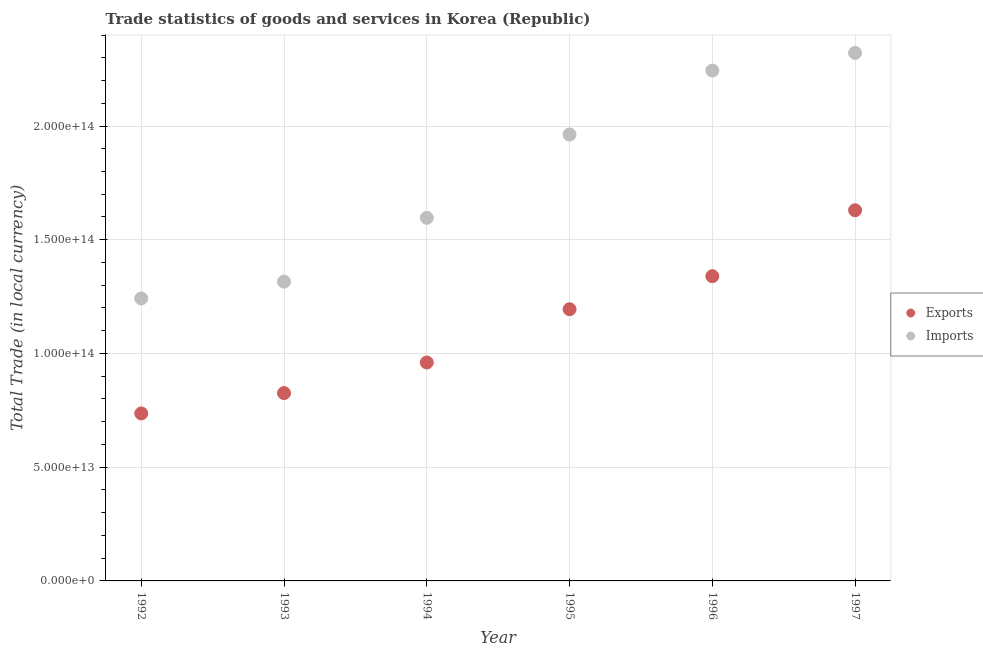What is the export of goods and services in 1995?
Ensure brevity in your answer.  1.19e+14. Across all years, what is the maximum imports of goods and services?
Your answer should be very brief. 2.32e+14. Across all years, what is the minimum export of goods and services?
Ensure brevity in your answer.  7.36e+13. What is the total imports of goods and services in the graph?
Offer a terse response. 1.07e+15. What is the difference between the imports of goods and services in 1995 and that in 1996?
Offer a very short reply. -2.81e+13. What is the difference between the imports of goods and services in 1996 and the export of goods and services in 1992?
Make the answer very short. 1.51e+14. What is the average imports of goods and services per year?
Provide a short and direct response. 1.78e+14. In the year 1995, what is the difference between the export of goods and services and imports of goods and services?
Make the answer very short. -7.68e+13. In how many years, is the export of goods and services greater than 130000000000000 LCU?
Provide a short and direct response. 2. What is the ratio of the imports of goods and services in 1993 to that in 1996?
Ensure brevity in your answer.  0.59. Is the difference between the export of goods and services in 1992 and 1997 greater than the difference between the imports of goods and services in 1992 and 1997?
Give a very brief answer. Yes. What is the difference between the highest and the second highest export of goods and services?
Offer a terse response. 2.90e+13. What is the difference between the highest and the lowest export of goods and services?
Provide a succinct answer. 8.93e+13. In how many years, is the export of goods and services greater than the average export of goods and services taken over all years?
Your answer should be very brief. 3. Is the sum of the imports of goods and services in 1994 and 1995 greater than the maximum export of goods and services across all years?
Your answer should be very brief. Yes. Does the imports of goods and services monotonically increase over the years?
Give a very brief answer. Yes. Is the export of goods and services strictly greater than the imports of goods and services over the years?
Give a very brief answer. No. Is the export of goods and services strictly less than the imports of goods and services over the years?
Ensure brevity in your answer.  Yes. What is the difference between two consecutive major ticks on the Y-axis?
Give a very brief answer. 5.00e+13. Are the values on the major ticks of Y-axis written in scientific E-notation?
Make the answer very short. Yes. How many legend labels are there?
Keep it short and to the point. 2. How are the legend labels stacked?
Give a very brief answer. Vertical. What is the title of the graph?
Your answer should be compact. Trade statistics of goods and services in Korea (Republic). Does "Commercial service imports" appear as one of the legend labels in the graph?
Keep it short and to the point. No. What is the label or title of the Y-axis?
Offer a terse response. Total Trade (in local currency). What is the Total Trade (in local currency) in Exports in 1992?
Provide a short and direct response. 7.36e+13. What is the Total Trade (in local currency) in Imports in 1992?
Your answer should be very brief. 1.24e+14. What is the Total Trade (in local currency) in Exports in 1993?
Your response must be concise. 8.26e+13. What is the Total Trade (in local currency) in Imports in 1993?
Ensure brevity in your answer.  1.32e+14. What is the Total Trade (in local currency) in Exports in 1994?
Offer a very short reply. 9.60e+13. What is the Total Trade (in local currency) in Imports in 1994?
Offer a very short reply. 1.60e+14. What is the Total Trade (in local currency) of Exports in 1995?
Offer a very short reply. 1.19e+14. What is the Total Trade (in local currency) of Imports in 1995?
Keep it short and to the point. 1.96e+14. What is the Total Trade (in local currency) of Exports in 1996?
Provide a short and direct response. 1.34e+14. What is the Total Trade (in local currency) of Imports in 1996?
Offer a very short reply. 2.24e+14. What is the Total Trade (in local currency) in Exports in 1997?
Make the answer very short. 1.63e+14. What is the Total Trade (in local currency) in Imports in 1997?
Provide a succinct answer. 2.32e+14. Across all years, what is the maximum Total Trade (in local currency) in Exports?
Make the answer very short. 1.63e+14. Across all years, what is the maximum Total Trade (in local currency) of Imports?
Provide a succinct answer. 2.32e+14. Across all years, what is the minimum Total Trade (in local currency) of Exports?
Your answer should be compact. 7.36e+13. Across all years, what is the minimum Total Trade (in local currency) in Imports?
Provide a succinct answer. 1.24e+14. What is the total Total Trade (in local currency) of Exports in the graph?
Ensure brevity in your answer.  6.69e+14. What is the total Total Trade (in local currency) of Imports in the graph?
Provide a succinct answer. 1.07e+15. What is the difference between the Total Trade (in local currency) in Exports in 1992 and that in 1993?
Offer a terse response. -8.95e+12. What is the difference between the Total Trade (in local currency) of Imports in 1992 and that in 1993?
Offer a very short reply. -7.39e+12. What is the difference between the Total Trade (in local currency) of Exports in 1992 and that in 1994?
Keep it short and to the point. -2.24e+13. What is the difference between the Total Trade (in local currency) of Imports in 1992 and that in 1994?
Give a very brief answer. -3.55e+13. What is the difference between the Total Trade (in local currency) of Exports in 1992 and that in 1995?
Your answer should be very brief. -4.58e+13. What is the difference between the Total Trade (in local currency) in Imports in 1992 and that in 1995?
Offer a terse response. -7.21e+13. What is the difference between the Total Trade (in local currency) in Exports in 1992 and that in 1996?
Make the answer very short. -6.03e+13. What is the difference between the Total Trade (in local currency) in Imports in 1992 and that in 1996?
Make the answer very short. -1.00e+14. What is the difference between the Total Trade (in local currency) in Exports in 1992 and that in 1997?
Your answer should be compact. -8.93e+13. What is the difference between the Total Trade (in local currency) of Imports in 1992 and that in 1997?
Your response must be concise. -1.08e+14. What is the difference between the Total Trade (in local currency) of Exports in 1993 and that in 1994?
Your answer should be compact. -1.34e+13. What is the difference between the Total Trade (in local currency) in Imports in 1993 and that in 1994?
Your response must be concise. -2.81e+13. What is the difference between the Total Trade (in local currency) of Exports in 1993 and that in 1995?
Give a very brief answer. -3.69e+13. What is the difference between the Total Trade (in local currency) in Imports in 1993 and that in 1995?
Your answer should be compact. -6.47e+13. What is the difference between the Total Trade (in local currency) of Exports in 1993 and that in 1996?
Your answer should be very brief. -5.14e+13. What is the difference between the Total Trade (in local currency) of Imports in 1993 and that in 1996?
Your answer should be very brief. -9.28e+13. What is the difference between the Total Trade (in local currency) of Exports in 1993 and that in 1997?
Keep it short and to the point. -8.04e+13. What is the difference between the Total Trade (in local currency) in Imports in 1993 and that in 1997?
Offer a very short reply. -1.01e+14. What is the difference between the Total Trade (in local currency) in Exports in 1994 and that in 1995?
Give a very brief answer. -2.34e+13. What is the difference between the Total Trade (in local currency) in Imports in 1994 and that in 1995?
Your answer should be compact. -3.66e+13. What is the difference between the Total Trade (in local currency) of Exports in 1994 and that in 1996?
Offer a terse response. -3.79e+13. What is the difference between the Total Trade (in local currency) in Imports in 1994 and that in 1996?
Provide a short and direct response. -6.47e+13. What is the difference between the Total Trade (in local currency) in Exports in 1994 and that in 1997?
Keep it short and to the point. -6.69e+13. What is the difference between the Total Trade (in local currency) of Imports in 1994 and that in 1997?
Provide a succinct answer. -7.25e+13. What is the difference between the Total Trade (in local currency) of Exports in 1995 and that in 1996?
Your response must be concise. -1.45e+13. What is the difference between the Total Trade (in local currency) in Imports in 1995 and that in 1996?
Offer a terse response. -2.81e+13. What is the difference between the Total Trade (in local currency) in Exports in 1995 and that in 1997?
Make the answer very short. -4.35e+13. What is the difference between the Total Trade (in local currency) in Imports in 1995 and that in 1997?
Provide a succinct answer. -3.59e+13. What is the difference between the Total Trade (in local currency) in Exports in 1996 and that in 1997?
Ensure brevity in your answer.  -2.90e+13. What is the difference between the Total Trade (in local currency) in Imports in 1996 and that in 1997?
Your response must be concise. -7.76e+12. What is the difference between the Total Trade (in local currency) in Exports in 1992 and the Total Trade (in local currency) in Imports in 1993?
Your response must be concise. -5.79e+13. What is the difference between the Total Trade (in local currency) in Exports in 1992 and the Total Trade (in local currency) in Imports in 1994?
Ensure brevity in your answer.  -8.60e+13. What is the difference between the Total Trade (in local currency) of Exports in 1992 and the Total Trade (in local currency) of Imports in 1995?
Keep it short and to the point. -1.23e+14. What is the difference between the Total Trade (in local currency) of Exports in 1992 and the Total Trade (in local currency) of Imports in 1996?
Your answer should be compact. -1.51e+14. What is the difference between the Total Trade (in local currency) of Exports in 1992 and the Total Trade (in local currency) of Imports in 1997?
Your answer should be very brief. -1.59e+14. What is the difference between the Total Trade (in local currency) of Exports in 1993 and the Total Trade (in local currency) of Imports in 1994?
Provide a succinct answer. -7.70e+13. What is the difference between the Total Trade (in local currency) of Exports in 1993 and the Total Trade (in local currency) of Imports in 1995?
Provide a succinct answer. -1.14e+14. What is the difference between the Total Trade (in local currency) in Exports in 1993 and the Total Trade (in local currency) in Imports in 1996?
Your answer should be compact. -1.42e+14. What is the difference between the Total Trade (in local currency) in Exports in 1993 and the Total Trade (in local currency) in Imports in 1997?
Provide a succinct answer. -1.50e+14. What is the difference between the Total Trade (in local currency) in Exports in 1994 and the Total Trade (in local currency) in Imports in 1995?
Offer a terse response. -1.00e+14. What is the difference between the Total Trade (in local currency) in Exports in 1994 and the Total Trade (in local currency) in Imports in 1996?
Provide a short and direct response. -1.28e+14. What is the difference between the Total Trade (in local currency) in Exports in 1994 and the Total Trade (in local currency) in Imports in 1997?
Your answer should be very brief. -1.36e+14. What is the difference between the Total Trade (in local currency) in Exports in 1995 and the Total Trade (in local currency) in Imports in 1996?
Your answer should be very brief. -1.05e+14. What is the difference between the Total Trade (in local currency) in Exports in 1995 and the Total Trade (in local currency) in Imports in 1997?
Your response must be concise. -1.13e+14. What is the difference between the Total Trade (in local currency) of Exports in 1996 and the Total Trade (in local currency) of Imports in 1997?
Offer a very short reply. -9.82e+13. What is the average Total Trade (in local currency) of Exports per year?
Give a very brief answer. 1.11e+14. What is the average Total Trade (in local currency) of Imports per year?
Make the answer very short. 1.78e+14. In the year 1992, what is the difference between the Total Trade (in local currency) in Exports and Total Trade (in local currency) in Imports?
Your response must be concise. -5.05e+13. In the year 1993, what is the difference between the Total Trade (in local currency) of Exports and Total Trade (in local currency) of Imports?
Offer a terse response. -4.90e+13. In the year 1994, what is the difference between the Total Trade (in local currency) in Exports and Total Trade (in local currency) in Imports?
Make the answer very short. -6.36e+13. In the year 1995, what is the difference between the Total Trade (in local currency) of Exports and Total Trade (in local currency) of Imports?
Your response must be concise. -7.68e+13. In the year 1996, what is the difference between the Total Trade (in local currency) in Exports and Total Trade (in local currency) in Imports?
Keep it short and to the point. -9.04e+13. In the year 1997, what is the difference between the Total Trade (in local currency) of Exports and Total Trade (in local currency) of Imports?
Make the answer very short. -6.92e+13. What is the ratio of the Total Trade (in local currency) in Exports in 1992 to that in 1993?
Your response must be concise. 0.89. What is the ratio of the Total Trade (in local currency) in Imports in 1992 to that in 1993?
Your answer should be very brief. 0.94. What is the ratio of the Total Trade (in local currency) of Exports in 1992 to that in 1994?
Offer a terse response. 0.77. What is the ratio of the Total Trade (in local currency) in Imports in 1992 to that in 1994?
Provide a short and direct response. 0.78. What is the ratio of the Total Trade (in local currency) of Exports in 1992 to that in 1995?
Ensure brevity in your answer.  0.62. What is the ratio of the Total Trade (in local currency) of Imports in 1992 to that in 1995?
Provide a short and direct response. 0.63. What is the ratio of the Total Trade (in local currency) of Exports in 1992 to that in 1996?
Your answer should be very brief. 0.55. What is the ratio of the Total Trade (in local currency) of Imports in 1992 to that in 1996?
Your response must be concise. 0.55. What is the ratio of the Total Trade (in local currency) in Exports in 1992 to that in 1997?
Make the answer very short. 0.45. What is the ratio of the Total Trade (in local currency) in Imports in 1992 to that in 1997?
Provide a succinct answer. 0.54. What is the ratio of the Total Trade (in local currency) in Exports in 1993 to that in 1994?
Ensure brevity in your answer.  0.86. What is the ratio of the Total Trade (in local currency) of Imports in 1993 to that in 1994?
Provide a succinct answer. 0.82. What is the ratio of the Total Trade (in local currency) of Exports in 1993 to that in 1995?
Give a very brief answer. 0.69. What is the ratio of the Total Trade (in local currency) of Imports in 1993 to that in 1995?
Your response must be concise. 0.67. What is the ratio of the Total Trade (in local currency) of Exports in 1993 to that in 1996?
Ensure brevity in your answer.  0.62. What is the ratio of the Total Trade (in local currency) of Imports in 1993 to that in 1996?
Offer a very short reply. 0.59. What is the ratio of the Total Trade (in local currency) of Exports in 1993 to that in 1997?
Keep it short and to the point. 0.51. What is the ratio of the Total Trade (in local currency) of Imports in 1993 to that in 1997?
Provide a succinct answer. 0.57. What is the ratio of the Total Trade (in local currency) in Exports in 1994 to that in 1995?
Keep it short and to the point. 0.8. What is the ratio of the Total Trade (in local currency) in Imports in 1994 to that in 1995?
Your response must be concise. 0.81. What is the ratio of the Total Trade (in local currency) in Exports in 1994 to that in 1996?
Make the answer very short. 0.72. What is the ratio of the Total Trade (in local currency) of Imports in 1994 to that in 1996?
Your answer should be compact. 0.71. What is the ratio of the Total Trade (in local currency) in Exports in 1994 to that in 1997?
Your answer should be very brief. 0.59. What is the ratio of the Total Trade (in local currency) in Imports in 1994 to that in 1997?
Provide a succinct answer. 0.69. What is the ratio of the Total Trade (in local currency) of Exports in 1995 to that in 1996?
Give a very brief answer. 0.89. What is the ratio of the Total Trade (in local currency) in Imports in 1995 to that in 1996?
Your answer should be compact. 0.87. What is the ratio of the Total Trade (in local currency) of Exports in 1995 to that in 1997?
Make the answer very short. 0.73. What is the ratio of the Total Trade (in local currency) in Imports in 1995 to that in 1997?
Provide a short and direct response. 0.85. What is the ratio of the Total Trade (in local currency) of Exports in 1996 to that in 1997?
Your response must be concise. 0.82. What is the ratio of the Total Trade (in local currency) in Imports in 1996 to that in 1997?
Your response must be concise. 0.97. What is the difference between the highest and the second highest Total Trade (in local currency) in Exports?
Your answer should be compact. 2.90e+13. What is the difference between the highest and the second highest Total Trade (in local currency) of Imports?
Your answer should be compact. 7.76e+12. What is the difference between the highest and the lowest Total Trade (in local currency) of Exports?
Give a very brief answer. 8.93e+13. What is the difference between the highest and the lowest Total Trade (in local currency) of Imports?
Offer a very short reply. 1.08e+14. 